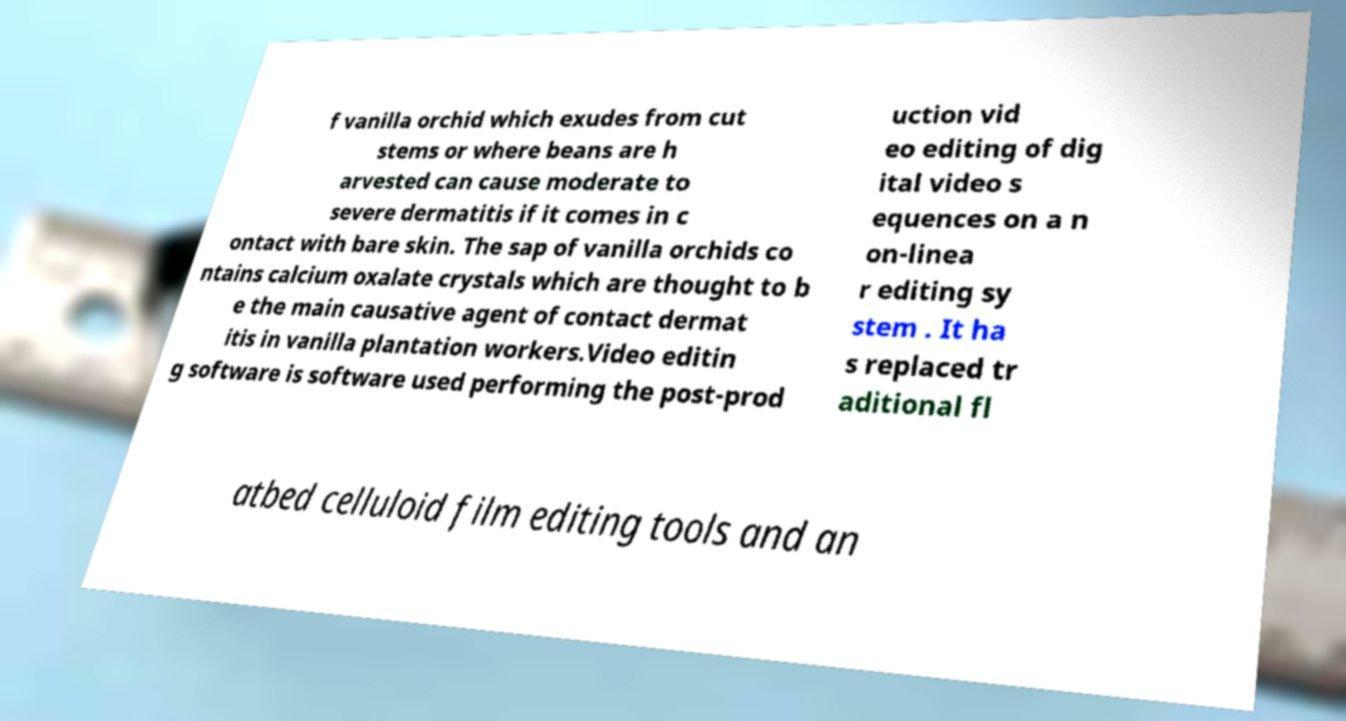Can you accurately transcribe the text from the provided image for me? f vanilla orchid which exudes from cut stems or where beans are h arvested can cause moderate to severe dermatitis if it comes in c ontact with bare skin. The sap of vanilla orchids co ntains calcium oxalate crystals which are thought to b e the main causative agent of contact dermat itis in vanilla plantation workers.Video editin g software is software used performing the post-prod uction vid eo editing of dig ital video s equences on a n on-linea r editing sy stem . It ha s replaced tr aditional fl atbed celluloid film editing tools and an 